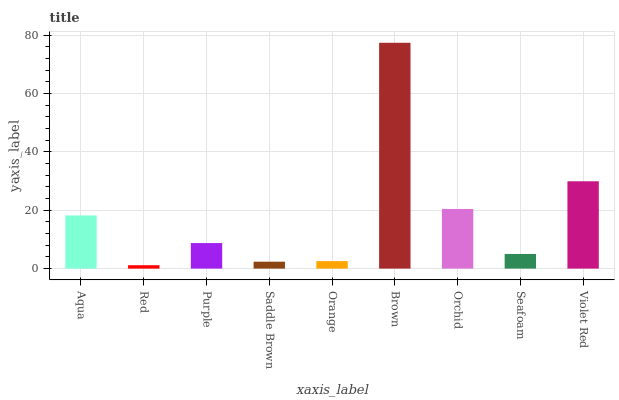Is Red the minimum?
Answer yes or no. Yes. Is Brown the maximum?
Answer yes or no. Yes. Is Purple the minimum?
Answer yes or no. No. Is Purple the maximum?
Answer yes or no. No. Is Purple greater than Red?
Answer yes or no. Yes. Is Red less than Purple?
Answer yes or no. Yes. Is Red greater than Purple?
Answer yes or no. No. Is Purple less than Red?
Answer yes or no. No. Is Purple the high median?
Answer yes or no. Yes. Is Purple the low median?
Answer yes or no. Yes. Is Aqua the high median?
Answer yes or no. No. Is Brown the low median?
Answer yes or no. No. 